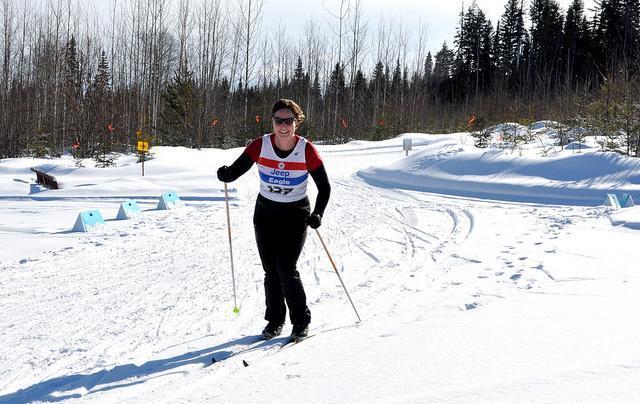How many elephants are present in the picture?
Give a very brief answer. 0. 